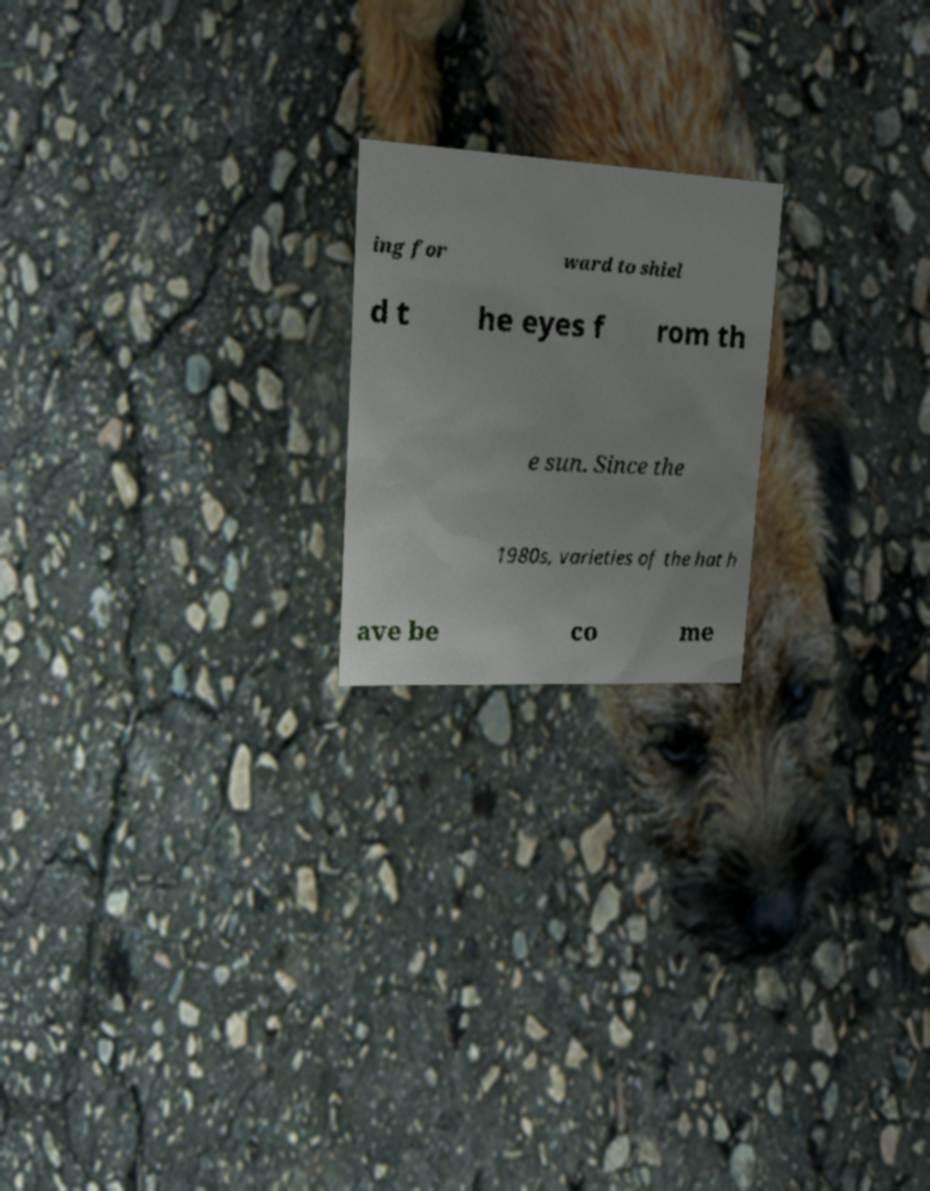Can you read and provide the text displayed in the image?This photo seems to have some interesting text. Can you extract and type it out for me? ing for ward to shiel d t he eyes f rom th e sun. Since the 1980s, varieties of the hat h ave be co me 